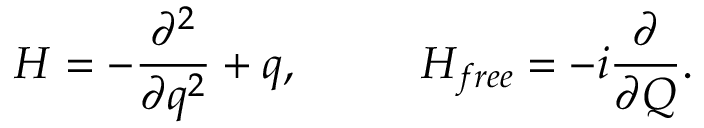Convert formula to latex. <formula><loc_0><loc_0><loc_500><loc_500>H = - { \frac { \partial ^ { 2 } } { \partial q ^ { 2 } } } + q , H _ { f r e e } = - i { \frac { \partial } \partial Q } } .</formula> 